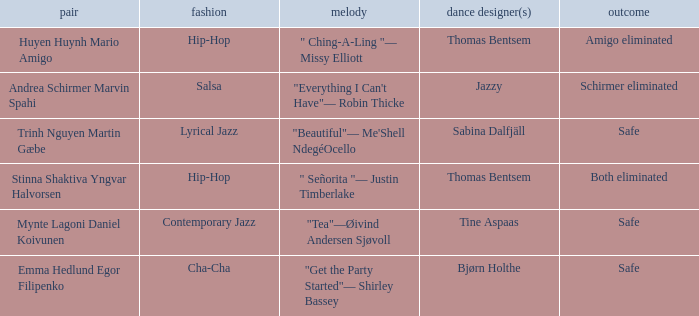What is the result of choreographer bjørn holthe? Safe. 